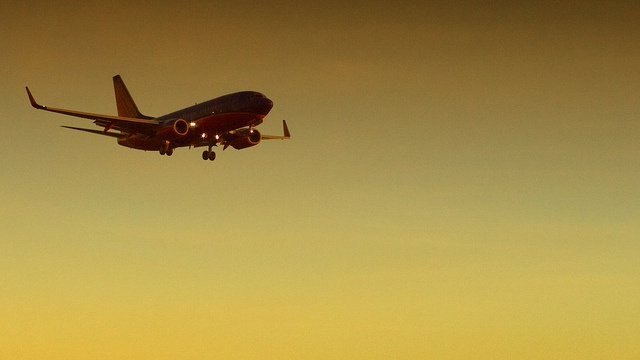Describe the objects in this image and their specific colors. I can see a airplane in maroon, black, and olive tones in this image. 